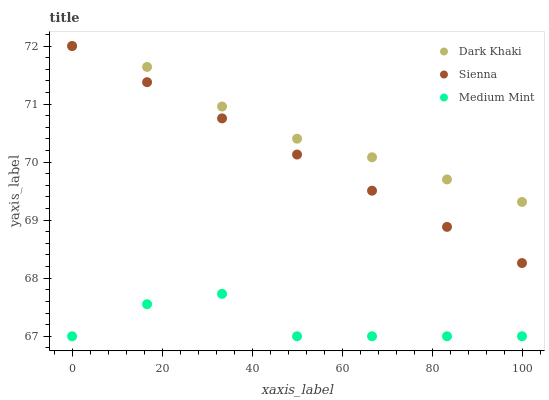Does Medium Mint have the minimum area under the curve?
Answer yes or no. Yes. Does Dark Khaki have the maximum area under the curve?
Answer yes or no. Yes. Does Sienna have the minimum area under the curve?
Answer yes or no. No. Does Sienna have the maximum area under the curve?
Answer yes or no. No. Is Sienna the smoothest?
Answer yes or no. Yes. Is Medium Mint the roughest?
Answer yes or no. Yes. Is Medium Mint the smoothest?
Answer yes or no. No. Is Sienna the roughest?
Answer yes or no. No. Does Medium Mint have the lowest value?
Answer yes or no. Yes. Does Sienna have the lowest value?
Answer yes or no. No. Does Sienna have the highest value?
Answer yes or no. Yes. Does Medium Mint have the highest value?
Answer yes or no. No. Is Medium Mint less than Dark Khaki?
Answer yes or no. Yes. Is Sienna greater than Medium Mint?
Answer yes or no. Yes. Does Sienna intersect Dark Khaki?
Answer yes or no. Yes. Is Sienna less than Dark Khaki?
Answer yes or no. No. Is Sienna greater than Dark Khaki?
Answer yes or no. No. Does Medium Mint intersect Dark Khaki?
Answer yes or no. No. 